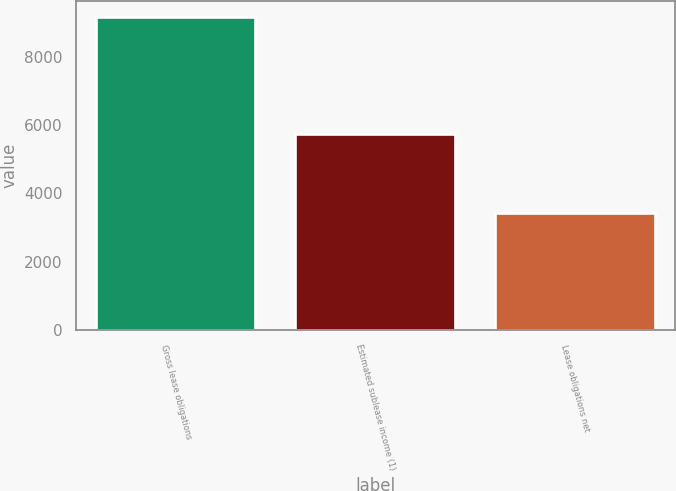<chart> <loc_0><loc_0><loc_500><loc_500><bar_chart><fcel>Gross lease obligations<fcel>Estimated sublease income (1)<fcel>Lease obligations net<nl><fcel>9167<fcel>5746<fcel>3421<nl></chart> 